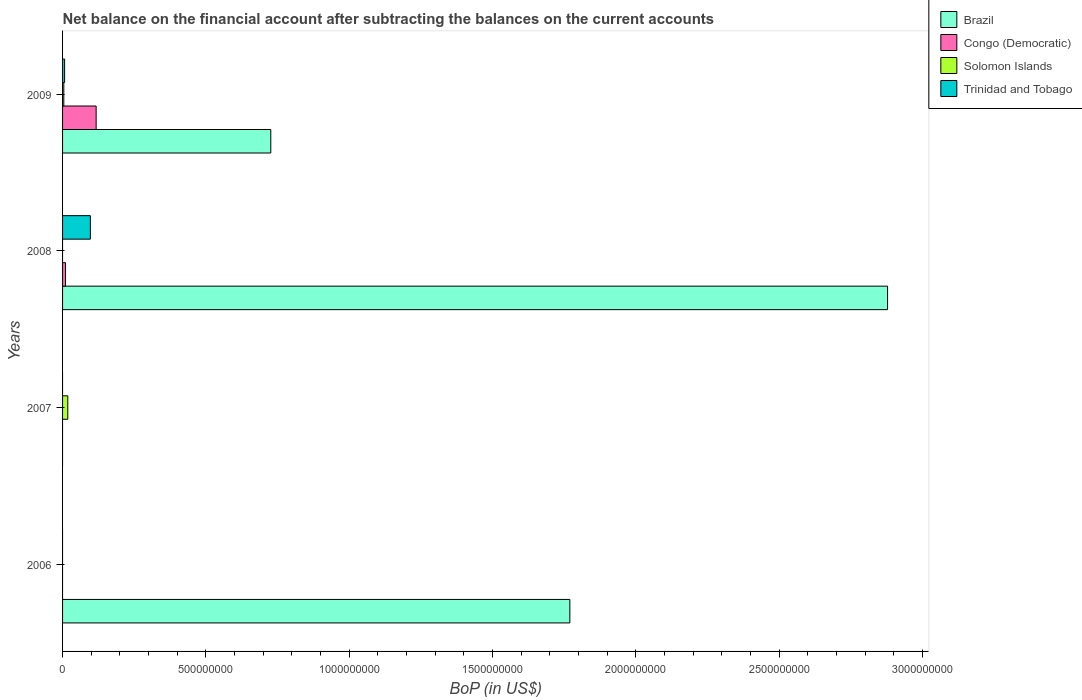How many different coloured bars are there?
Give a very brief answer. 4. In how many cases, is the number of bars for a given year not equal to the number of legend labels?
Offer a terse response. 3. What is the Balance of Payments in Solomon Islands in 2007?
Offer a terse response. 1.83e+07. Across all years, what is the maximum Balance of Payments in Brazil?
Make the answer very short. 2.88e+09. Across all years, what is the minimum Balance of Payments in Solomon Islands?
Your response must be concise. 0. In which year was the Balance of Payments in Brazil maximum?
Make the answer very short. 2008. What is the total Balance of Payments in Solomon Islands in the graph?
Offer a very short reply. 2.26e+07. What is the difference between the Balance of Payments in Trinidad and Tobago in 2008 and that in 2009?
Provide a succinct answer. 8.98e+07. What is the difference between the Balance of Payments in Brazil in 2006 and the Balance of Payments in Congo (Democratic) in 2008?
Your response must be concise. 1.76e+09. What is the average Balance of Payments in Solomon Islands per year?
Provide a succinct answer. 5.65e+06. In the year 2008, what is the difference between the Balance of Payments in Trinidad and Tobago and Balance of Payments in Brazil?
Offer a very short reply. -2.78e+09. In how many years, is the Balance of Payments in Congo (Democratic) greater than 2600000000 US$?
Offer a terse response. 0. What is the ratio of the Balance of Payments in Trinidad and Tobago in 2008 to that in 2009?
Your answer should be very brief. 13.61. Is the Balance of Payments in Trinidad and Tobago in 2008 less than that in 2009?
Ensure brevity in your answer.  No. What is the difference between the highest and the second highest Balance of Payments in Brazil?
Ensure brevity in your answer.  1.11e+09. What is the difference between the highest and the lowest Balance of Payments in Brazil?
Ensure brevity in your answer.  2.88e+09. How many legend labels are there?
Your answer should be very brief. 4. What is the title of the graph?
Give a very brief answer. Net balance on the financial account after subtracting the balances on the current accounts. What is the label or title of the X-axis?
Your answer should be compact. BoP (in US$). What is the label or title of the Y-axis?
Provide a short and direct response. Years. What is the BoP (in US$) of Brazil in 2006?
Offer a very short reply. 1.77e+09. What is the BoP (in US$) in Congo (Democratic) in 2006?
Provide a short and direct response. 0. What is the BoP (in US$) in Solomon Islands in 2006?
Your answer should be very brief. 0. What is the BoP (in US$) in Congo (Democratic) in 2007?
Make the answer very short. 0. What is the BoP (in US$) in Solomon Islands in 2007?
Ensure brevity in your answer.  1.83e+07. What is the BoP (in US$) of Brazil in 2008?
Your answer should be compact. 2.88e+09. What is the BoP (in US$) of Congo (Democratic) in 2008?
Make the answer very short. 1.03e+07. What is the BoP (in US$) in Trinidad and Tobago in 2008?
Offer a terse response. 9.70e+07. What is the BoP (in US$) in Brazil in 2009?
Make the answer very short. 7.26e+08. What is the BoP (in US$) in Congo (Democratic) in 2009?
Provide a succinct answer. 1.17e+08. What is the BoP (in US$) of Solomon Islands in 2009?
Offer a terse response. 4.36e+06. What is the BoP (in US$) in Trinidad and Tobago in 2009?
Ensure brevity in your answer.  7.12e+06. Across all years, what is the maximum BoP (in US$) of Brazil?
Give a very brief answer. 2.88e+09. Across all years, what is the maximum BoP (in US$) in Congo (Democratic)?
Offer a very short reply. 1.17e+08. Across all years, what is the maximum BoP (in US$) of Solomon Islands?
Offer a terse response. 1.83e+07. Across all years, what is the maximum BoP (in US$) in Trinidad and Tobago?
Ensure brevity in your answer.  9.70e+07. Across all years, what is the minimum BoP (in US$) in Trinidad and Tobago?
Offer a terse response. 0. What is the total BoP (in US$) of Brazil in the graph?
Your response must be concise. 5.37e+09. What is the total BoP (in US$) of Congo (Democratic) in the graph?
Provide a short and direct response. 1.27e+08. What is the total BoP (in US$) in Solomon Islands in the graph?
Your answer should be very brief. 2.26e+07. What is the total BoP (in US$) of Trinidad and Tobago in the graph?
Make the answer very short. 1.04e+08. What is the difference between the BoP (in US$) in Brazil in 2006 and that in 2008?
Keep it short and to the point. -1.11e+09. What is the difference between the BoP (in US$) in Brazil in 2006 and that in 2009?
Your response must be concise. 1.04e+09. What is the difference between the BoP (in US$) in Solomon Islands in 2007 and that in 2009?
Keep it short and to the point. 1.39e+07. What is the difference between the BoP (in US$) of Brazil in 2008 and that in 2009?
Give a very brief answer. 2.15e+09. What is the difference between the BoP (in US$) in Congo (Democratic) in 2008 and that in 2009?
Provide a succinct answer. -1.07e+08. What is the difference between the BoP (in US$) of Trinidad and Tobago in 2008 and that in 2009?
Your answer should be very brief. 8.98e+07. What is the difference between the BoP (in US$) of Brazil in 2006 and the BoP (in US$) of Solomon Islands in 2007?
Your answer should be very brief. 1.75e+09. What is the difference between the BoP (in US$) in Brazil in 2006 and the BoP (in US$) in Congo (Democratic) in 2008?
Your answer should be compact. 1.76e+09. What is the difference between the BoP (in US$) in Brazil in 2006 and the BoP (in US$) in Trinidad and Tobago in 2008?
Keep it short and to the point. 1.67e+09. What is the difference between the BoP (in US$) of Brazil in 2006 and the BoP (in US$) of Congo (Democratic) in 2009?
Make the answer very short. 1.65e+09. What is the difference between the BoP (in US$) of Brazil in 2006 and the BoP (in US$) of Solomon Islands in 2009?
Offer a very short reply. 1.77e+09. What is the difference between the BoP (in US$) in Brazil in 2006 and the BoP (in US$) in Trinidad and Tobago in 2009?
Provide a short and direct response. 1.76e+09. What is the difference between the BoP (in US$) of Solomon Islands in 2007 and the BoP (in US$) of Trinidad and Tobago in 2008?
Offer a very short reply. -7.87e+07. What is the difference between the BoP (in US$) of Solomon Islands in 2007 and the BoP (in US$) of Trinidad and Tobago in 2009?
Offer a very short reply. 1.11e+07. What is the difference between the BoP (in US$) in Brazil in 2008 and the BoP (in US$) in Congo (Democratic) in 2009?
Ensure brevity in your answer.  2.76e+09. What is the difference between the BoP (in US$) of Brazil in 2008 and the BoP (in US$) of Solomon Islands in 2009?
Give a very brief answer. 2.87e+09. What is the difference between the BoP (in US$) of Brazil in 2008 and the BoP (in US$) of Trinidad and Tobago in 2009?
Your answer should be very brief. 2.87e+09. What is the difference between the BoP (in US$) in Congo (Democratic) in 2008 and the BoP (in US$) in Solomon Islands in 2009?
Provide a succinct answer. 5.94e+06. What is the difference between the BoP (in US$) of Congo (Democratic) in 2008 and the BoP (in US$) of Trinidad and Tobago in 2009?
Your answer should be compact. 3.18e+06. What is the average BoP (in US$) of Brazil per year?
Keep it short and to the point. 1.34e+09. What is the average BoP (in US$) in Congo (Democratic) per year?
Give a very brief answer. 3.19e+07. What is the average BoP (in US$) of Solomon Islands per year?
Ensure brevity in your answer.  5.65e+06. What is the average BoP (in US$) of Trinidad and Tobago per year?
Offer a very short reply. 2.60e+07. In the year 2008, what is the difference between the BoP (in US$) in Brazil and BoP (in US$) in Congo (Democratic)?
Offer a terse response. 2.87e+09. In the year 2008, what is the difference between the BoP (in US$) of Brazil and BoP (in US$) of Trinidad and Tobago?
Make the answer very short. 2.78e+09. In the year 2008, what is the difference between the BoP (in US$) in Congo (Democratic) and BoP (in US$) in Trinidad and Tobago?
Provide a succinct answer. -8.67e+07. In the year 2009, what is the difference between the BoP (in US$) in Brazil and BoP (in US$) in Congo (Democratic)?
Provide a succinct answer. 6.09e+08. In the year 2009, what is the difference between the BoP (in US$) of Brazil and BoP (in US$) of Solomon Islands?
Offer a terse response. 7.22e+08. In the year 2009, what is the difference between the BoP (in US$) in Brazil and BoP (in US$) in Trinidad and Tobago?
Offer a terse response. 7.19e+08. In the year 2009, what is the difference between the BoP (in US$) in Congo (Democratic) and BoP (in US$) in Solomon Islands?
Keep it short and to the point. 1.13e+08. In the year 2009, what is the difference between the BoP (in US$) of Congo (Democratic) and BoP (in US$) of Trinidad and Tobago?
Give a very brief answer. 1.10e+08. In the year 2009, what is the difference between the BoP (in US$) of Solomon Islands and BoP (in US$) of Trinidad and Tobago?
Give a very brief answer. -2.77e+06. What is the ratio of the BoP (in US$) in Brazil in 2006 to that in 2008?
Your answer should be very brief. 0.61. What is the ratio of the BoP (in US$) in Brazil in 2006 to that in 2009?
Offer a terse response. 2.44. What is the ratio of the BoP (in US$) in Solomon Islands in 2007 to that in 2009?
Provide a succinct answer. 4.19. What is the ratio of the BoP (in US$) of Brazil in 2008 to that in 2009?
Give a very brief answer. 3.96. What is the ratio of the BoP (in US$) in Congo (Democratic) in 2008 to that in 2009?
Provide a succinct answer. 0.09. What is the ratio of the BoP (in US$) of Trinidad and Tobago in 2008 to that in 2009?
Give a very brief answer. 13.61. What is the difference between the highest and the second highest BoP (in US$) of Brazil?
Offer a terse response. 1.11e+09. What is the difference between the highest and the lowest BoP (in US$) of Brazil?
Provide a short and direct response. 2.88e+09. What is the difference between the highest and the lowest BoP (in US$) of Congo (Democratic)?
Offer a very short reply. 1.17e+08. What is the difference between the highest and the lowest BoP (in US$) of Solomon Islands?
Offer a very short reply. 1.83e+07. What is the difference between the highest and the lowest BoP (in US$) in Trinidad and Tobago?
Your answer should be compact. 9.70e+07. 